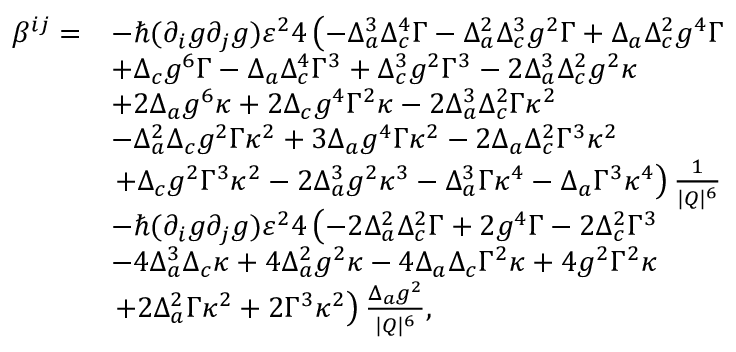Convert formula to latex. <formula><loc_0><loc_0><loc_500><loc_500>\begin{array} { r l } { \beta ^ { i j } = } & { - \hbar { ( } \partial _ { i } g \partial _ { j } g ) \varepsilon ^ { 2 } 4 \left ( - \Delta _ { a } ^ { 3 } \Delta _ { c } ^ { 4 } \Gamma - \Delta _ { a } ^ { 2 } \Delta _ { c } ^ { 3 } g ^ { 2 } \Gamma + \Delta _ { a } \Delta _ { c } ^ { 2 } g ^ { 4 } \Gamma } \\ & { + \Delta _ { c } g ^ { 6 } \Gamma - \Delta _ { a } \Delta _ { c } ^ { 4 } \Gamma ^ { 3 } + \Delta _ { c } ^ { 3 } g ^ { 2 } \Gamma ^ { 3 } - 2 \Delta _ { a } ^ { 3 } \Delta _ { c } ^ { 2 } g ^ { 2 } \kappa } \\ & { + 2 \Delta _ { a } g ^ { 6 } \kappa + 2 \Delta _ { c } g ^ { 4 } \Gamma ^ { 2 } \kappa - 2 \Delta _ { a } ^ { 3 } \Delta _ { c } ^ { 2 } \Gamma \kappa ^ { 2 } } \\ & { - \Delta _ { a } ^ { 2 } \Delta _ { c } g ^ { 2 } \Gamma \kappa ^ { 2 } + 3 \Delta _ { a } g ^ { 4 } \Gamma \kappa ^ { 2 } - 2 \Delta _ { a } \Delta _ { c } ^ { 2 } \Gamma ^ { 3 } \kappa ^ { 2 } } \\ & { + \Delta _ { c } g ^ { 2 } \Gamma ^ { 3 } \kappa ^ { 2 } - 2 \Delta _ { a } ^ { 3 } g ^ { 2 } \kappa ^ { 3 } - \Delta _ { a } ^ { 3 } \Gamma \kappa ^ { 4 } - \Delta _ { a } \Gamma ^ { 3 } \kappa ^ { 4 } \right ) \frac { 1 } { | Q | ^ { 6 } } } \\ & { - \hbar { ( } \partial _ { i } g \partial _ { j } g ) \varepsilon ^ { 2 } 4 \left ( - 2 \Delta _ { a } ^ { 2 } \Delta _ { c } ^ { 2 } \Gamma + 2 g ^ { 4 } \Gamma - 2 \Delta _ { c } ^ { 2 } \Gamma ^ { 3 } } \\ & { - 4 \Delta _ { a } ^ { 3 } \Delta _ { c } \kappa + 4 \Delta _ { a } ^ { 2 } g ^ { 2 } \kappa - 4 \Delta _ { a } \Delta _ { c } \Gamma ^ { 2 } \kappa + 4 g ^ { 2 } \Gamma ^ { 2 } \kappa } \\ & { + 2 \Delta _ { a } ^ { 2 } \Gamma \kappa ^ { 2 } + 2 \Gamma ^ { 3 } \kappa ^ { 2 } \right ) \frac { \Delta _ { a } g ^ { 2 } } { | Q | ^ { 6 } } , } \end{array}</formula> 